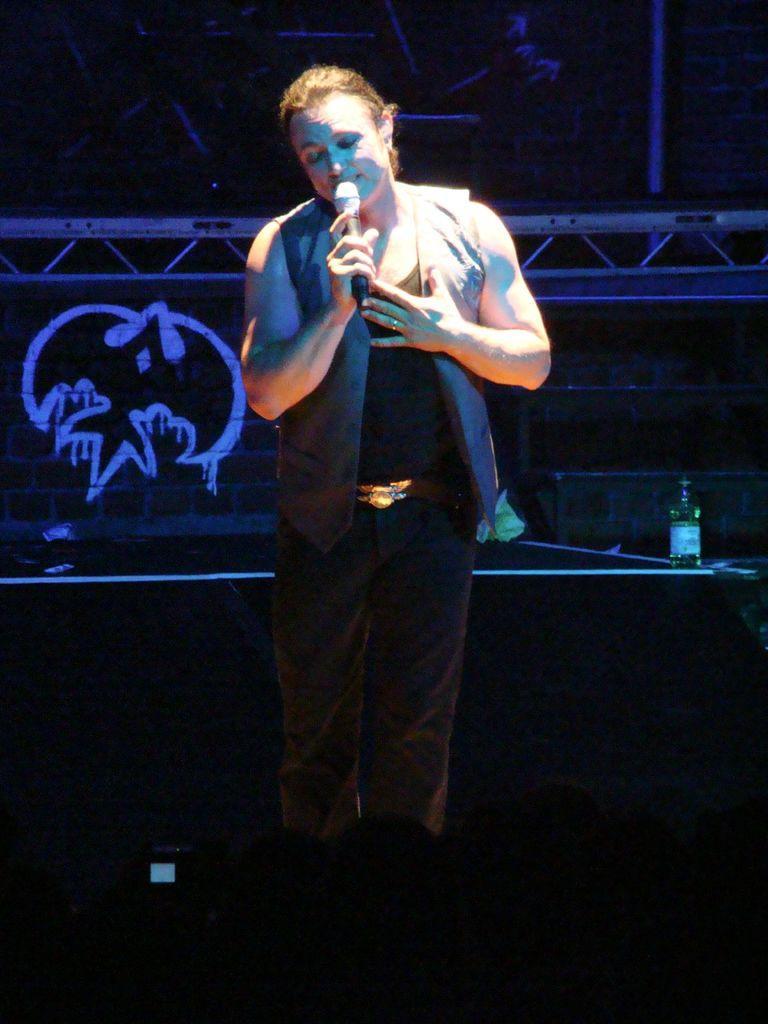Could you give a brief overview of what you see in this image? In this image we can see a person is holding a mike. In the background we can see wall, bottle, and other objects. At the bottom of the image it is dark and we can see a mobile. 